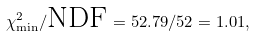<formula> <loc_0><loc_0><loc_500><loc_500>\chi ^ { 2 } _ { \min } / \text {NDF} = 5 2 . 7 9 / 5 2 = 1 . 0 1 ,</formula> 